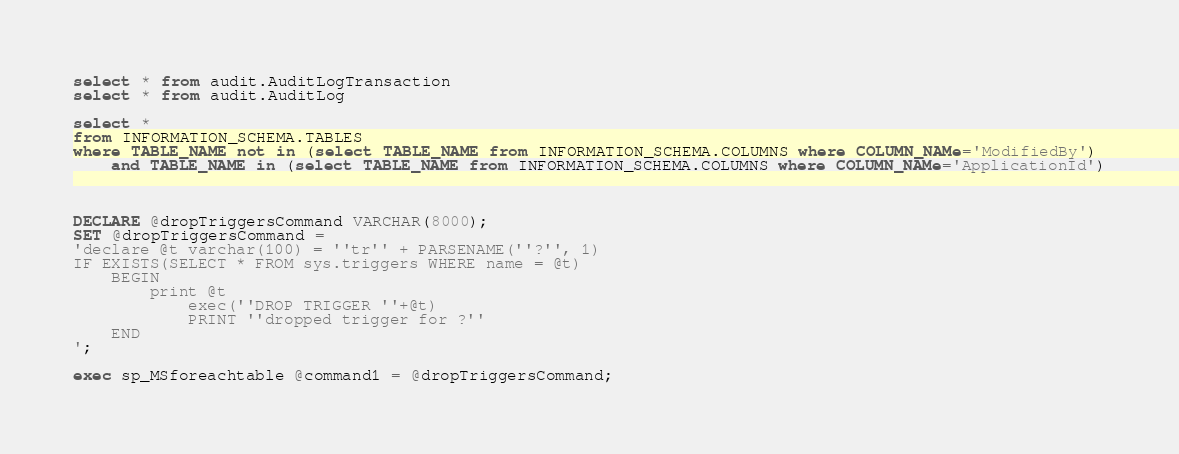Convert code to text. <code><loc_0><loc_0><loc_500><loc_500><_SQL_>select * from audit.AuditLogTransaction
select * from audit.AuditLog

select * 
from INFORMATION_SCHEMA.TABLES 
where TABLE_NAME not in (select TABLE_NAME from INFORMATION_SCHEMA.COLUMNS where COLUMN_NAMe='ModifiedBy')
	and TABLE_NAME in (select TABLE_NAME from INFORMATION_SCHEMA.COLUMNS where COLUMN_NAMe='ApplicationId')



DECLARE @dropTriggersCommand VARCHAR(8000);
SET @dropTriggersCommand = 
'declare @t varchar(100) = ''tr'' + PARSENAME(''?'', 1)
IF EXISTS(SELECT * FROM sys.triggers WHERE name = @t) 
	BEGIN
		print @t
			exec(''DROP TRIGGER ''+@t)
			PRINT ''dropped trigger for ?''
	END
';

exec sp_MSforeachtable @command1 = @dropTriggersCommand;
</code> 